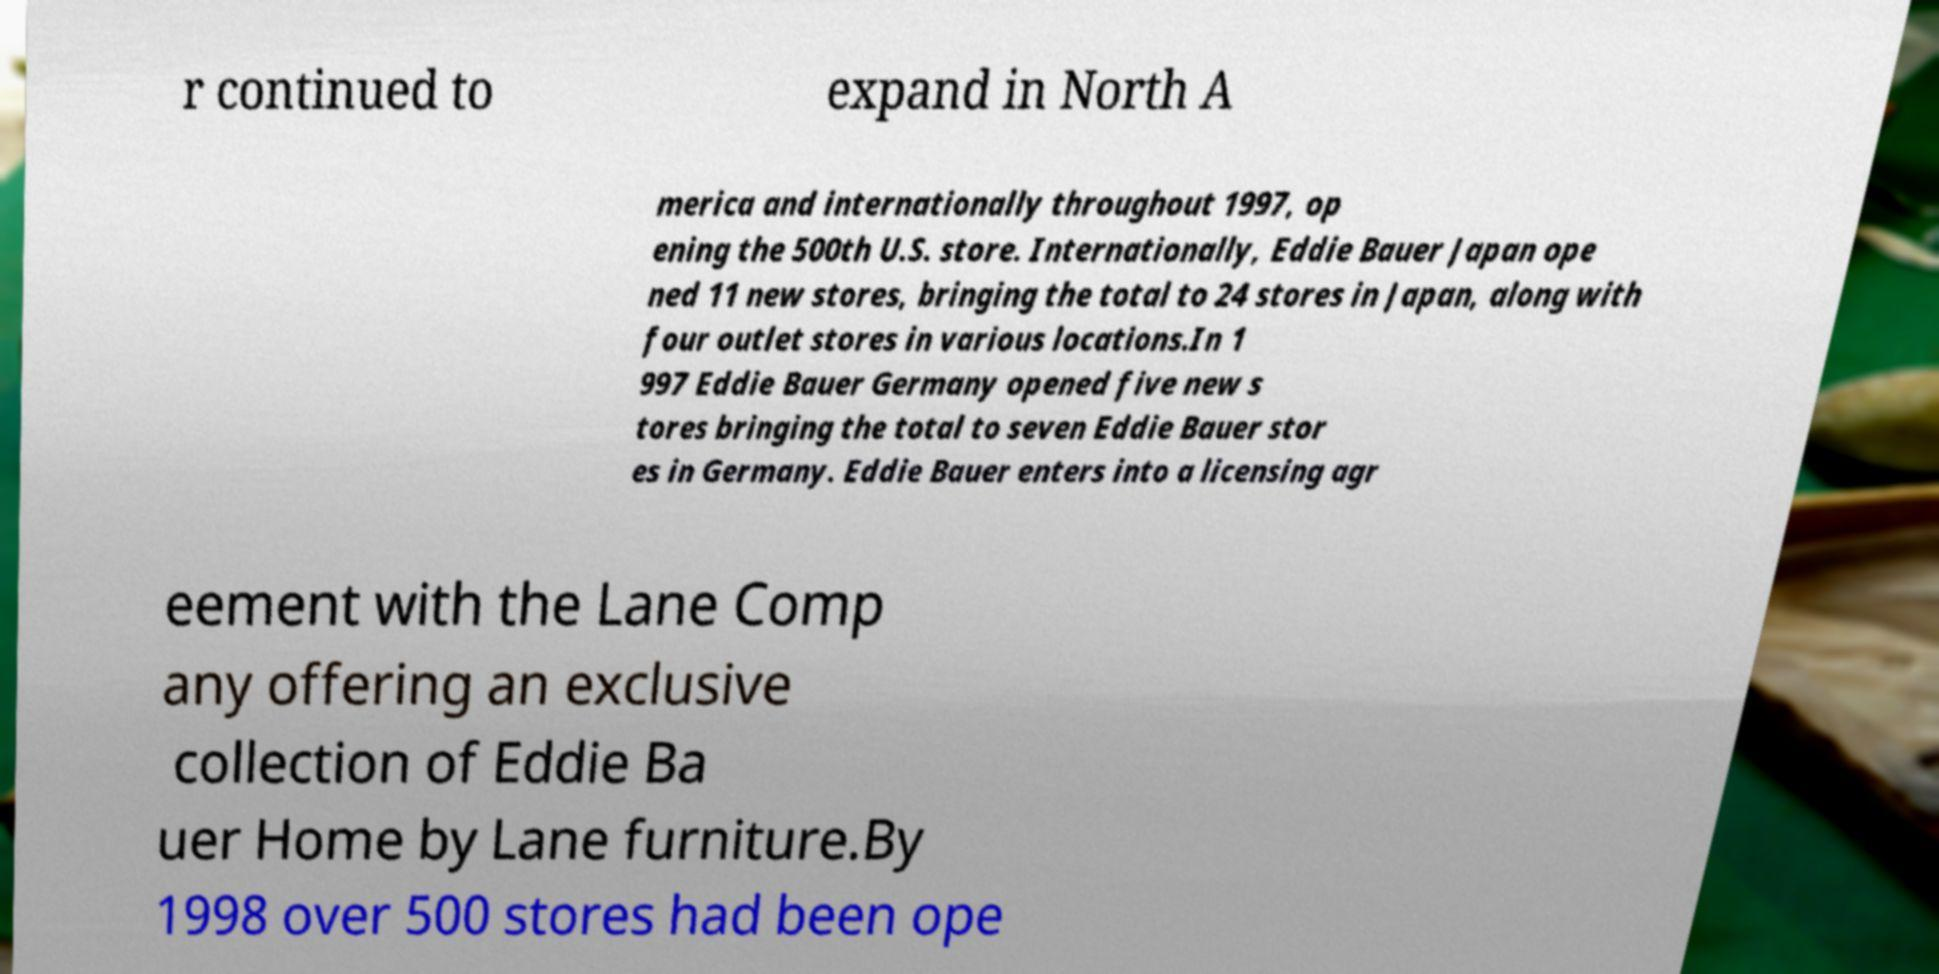Please read and relay the text visible in this image. What does it say? r continued to expand in North A merica and internationally throughout 1997, op ening the 500th U.S. store. Internationally, Eddie Bauer Japan ope ned 11 new stores, bringing the total to 24 stores in Japan, along with four outlet stores in various locations.In 1 997 Eddie Bauer Germany opened five new s tores bringing the total to seven Eddie Bauer stor es in Germany. Eddie Bauer enters into a licensing agr eement with the Lane Comp any offering an exclusive collection of Eddie Ba uer Home by Lane furniture.By 1998 over 500 stores had been ope 